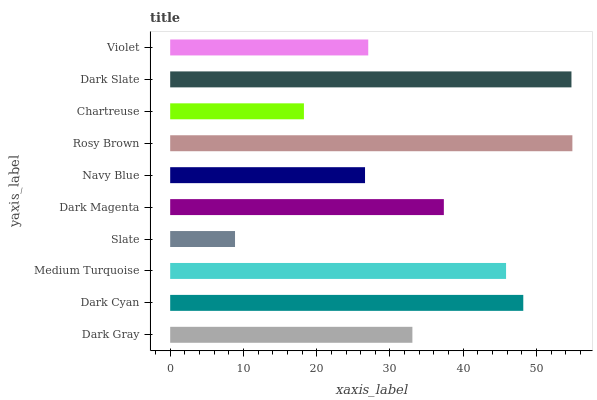Is Slate the minimum?
Answer yes or no. Yes. Is Rosy Brown the maximum?
Answer yes or no. Yes. Is Dark Cyan the minimum?
Answer yes or no. No. Is Dark Cyan the maximum?
Answer yes or no. No. Is Dark Cyan greater than Dark Gray?
Answer yes or no. Yes. Is Dark Gray less than Dark Cyan?
Answer yes or no. Yes. Is Dark Gray greater than Dark Cyan?
Answer yes or no. No. Is Dark Cyan less than Dark Gray?
Answer yes or no. No. Is Dark Magenta the high median?
Answer yes or no. Yes. Is Dark Gray the low median?
Answer yes or no. Yes. Is Rosy Brown the high median?
Answer yes or no. No. Is Rosy Brown the low median?
Answer yes or no. No. 